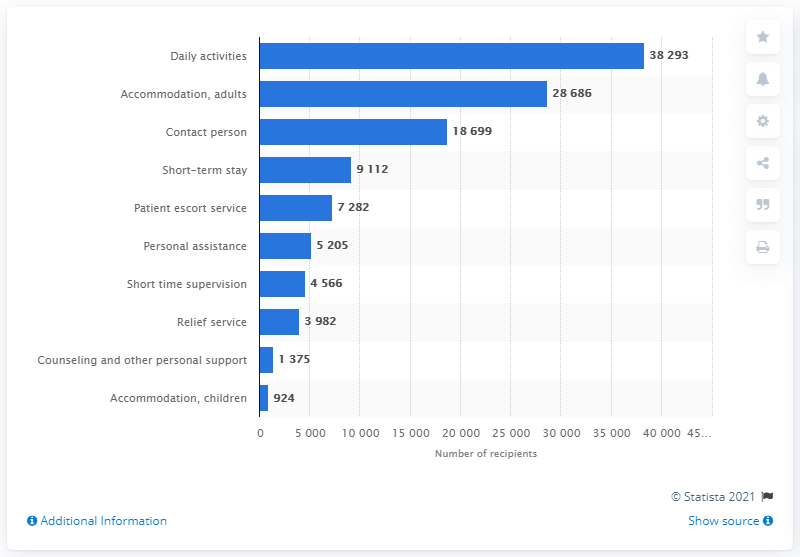Indicate a few pertinent items in this graphic. In 2019, a total of 38,293 people in Sweden received daily activity services. 